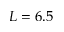<formula> <loc_0><loc_0><loc_500><loc_500>L = 6 . 5</formula> 